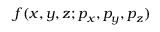Convert formula to latex. <formula><loc_0><loc_0><loc_500><loc_500>f ( x , y , z ; p _ { x } , p _ { y } , p _ { z } )</formula> 